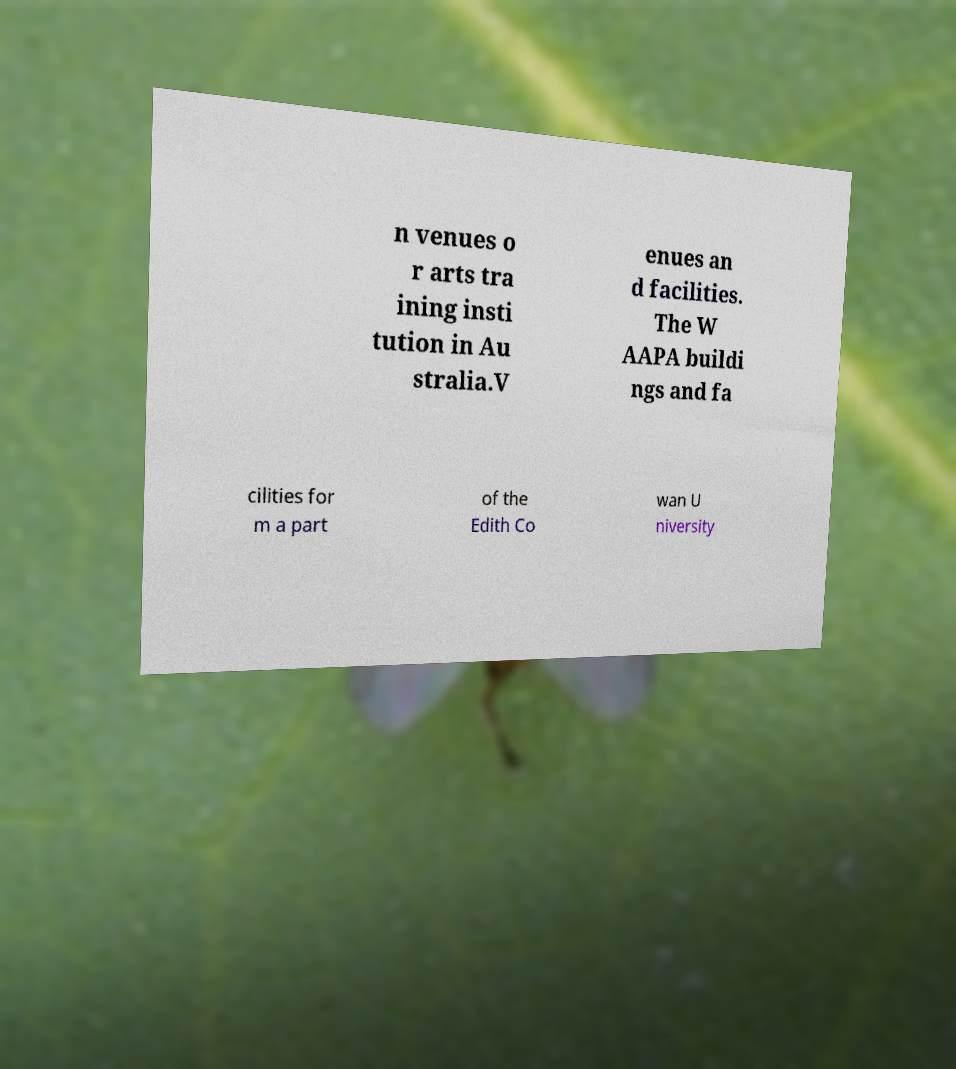Please identify and transcribe the text found in this image. n venues o r arts tra ining insti tution in Au stralia.V enues an d facilities. The W AAPA buildi ngs and fa cilities for m a part of the Edith Co wan U niversity 